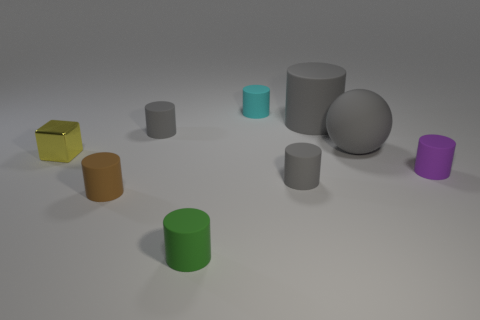How many other things are there of the same shape as the small cyan matte object?
Provide a short and direct response. 6. Are there more purple rubber things on the left side of the tiny green matte cylinder than brown things on the left side of the brown rubber cylinder?
Your response must be concise. No. Do the brown rubber thing that is in front of the purple matte object and the gray ball that is behind the tiny brown object have the same size?
Your response must be concise. No. What shape is the tiny yellow shiny thing?
Your answer should be very brief. Cube. What size is the rubber sphere that is the same color as the large rubber cylinder?
Give a very brief answer. Large. The large ball that is the same material as the purple thing is what color?
Ensure brevity in your answer.  Gray. Is the material of the small yellow cube the same as the small cylinder to the right of the big gray cylinder?
Offer a very short reply. No. The shiny cube has what color?
Your response must be concise. Yellow. There is a sphere that is the same material as the large cylinder; what is its size?
Keep it short and to the point. Large. How many tiny purple things are on the left side of the small gray matte cylinder that is to the left of the gray rubber thing in front of the yellow cube?
Make the answer very short. 0. 